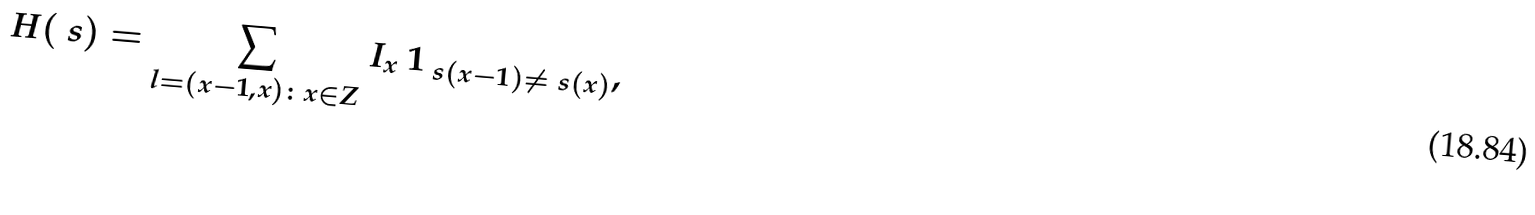<formula> <loc_0><loc_0><loc_500><loc_500>H ( \ s ) = \sum _ { l = ( x - 1 , x ) \colon x \in Z } I _ { x } \ 1 _ { \ s ( x - 1 ) \ne \ s ( x ) } ,</formula> 